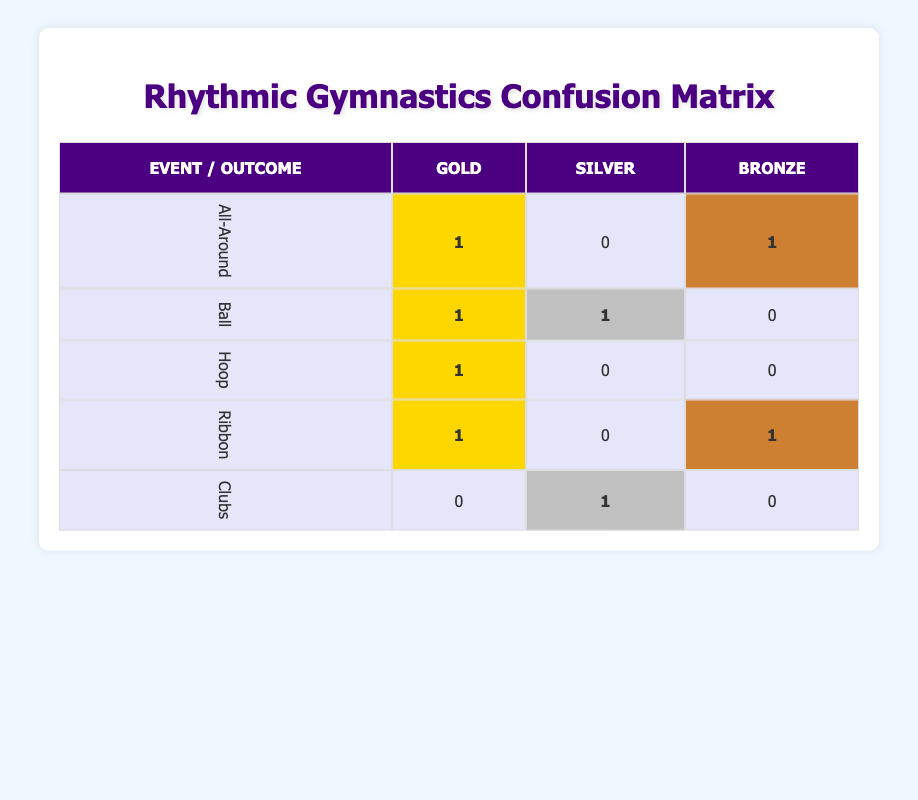What is the total number of Gold medals awarded in the All-Around event? In the All-Around row, the Gold cell shows "1", indicating that there is one Gold medal awarded in this event.
Answer: 1 Which event has the highest number of medals overall? To determine this, sum the values for each event: All-Around (2), Ball (2), Hoop (1), Ribbon (2), and Clubs (1), which gives a maximum of 2 for Ball and All-Around. Thus, these events are tied for the highest number of medals overall, with 2 medals each.
Answer: All-Around and Ball Did any athlete win a Gold medal in the Ribbon event? Looking at the Ribbon row, the Gold cell shows "1", indicating that there is one Gold medal awarded in the Ribbon event.
Answer: Yes What is the difference in the number of Gold and Silver medals awarded in the Ball event? For the Ball event, the Gold cell shows "1" and the Silver cell shows "1". To find the difference, subtract the number of Silver medals from the number of Gold medals: 1 - 1 = 0.
Answer: 0 How many athletes won medals in the Tokyo Olympics? From the table, the Tokyo Olympics medals are won by Yana Kudryavtseva, Rosa Galvez, Dina Averina, Son Yeon-Jae, and Lino Vasileva, totaling 5 athletes.
Answer: 5 Which event had both Gold and Silver medals awarded? Analyzing the events, both the Ball event (Gold: 1, Silver: 1) and All-Around event (Gold: 1) show medals awarded. However, only the Ball event has both Gold and Silver medals.
Answer: Ball Was there any event that had no Gold medals awarded? Looking at each event, Clubs shows "0" for Gold. Therefore, Clubs is the event where no Gold medals were awarded.
Answer: Yes How many events had at least one Bronze medal awarded? Reviewing the events, the All-Around, Ribbon, and Ribbon events all have Bronze with a total of 3 distinct events listed.
Answer: 3 